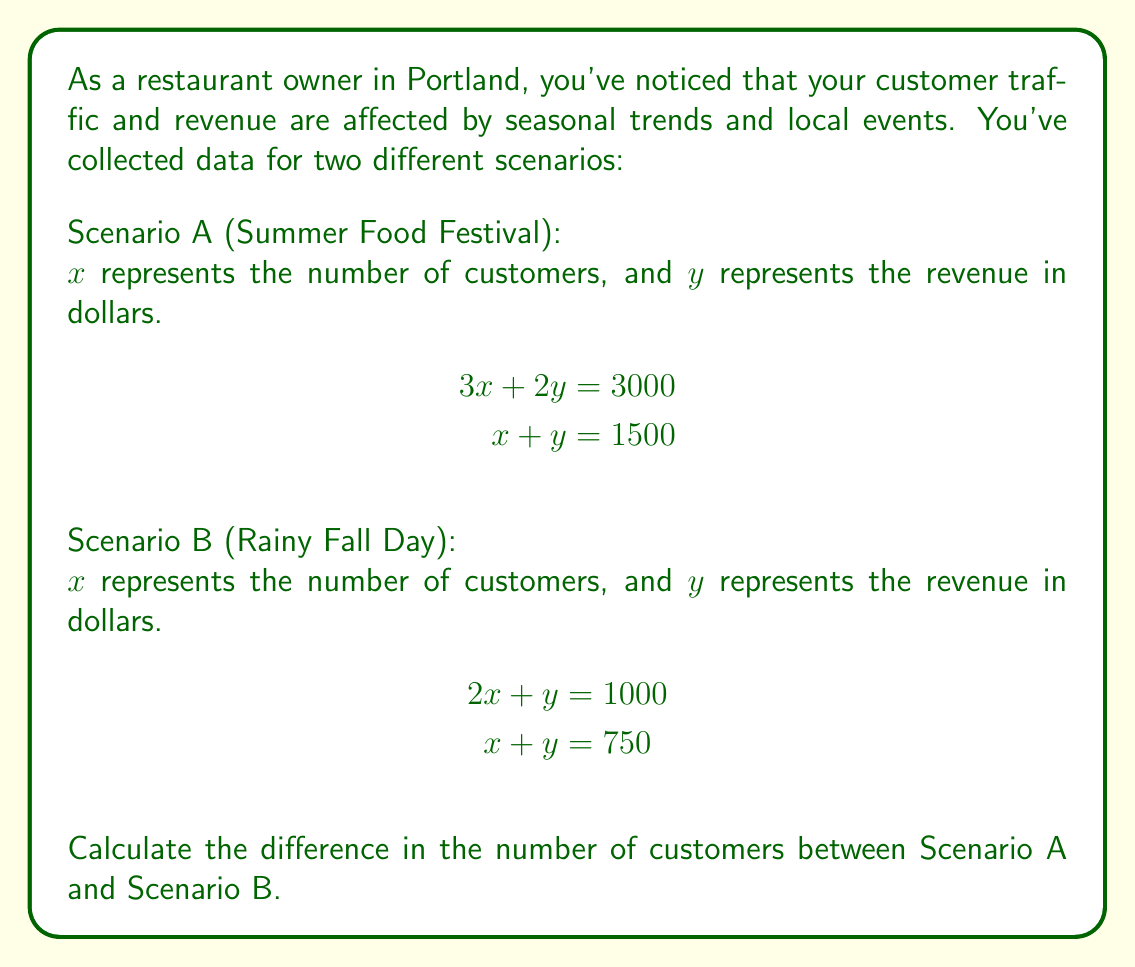Solve this math problem. Let's solve this problem step by step using systems of equations for each scenario:

Scenario A (Summer Food Festival):
$$3x + 2y = 3000 \quad (1)$$
$$x + y = 1500 \quad (2)$$

To solve this system, let's use substitution:
From equation (2): $y = 1500 - x$
Substitute this into equation (1):
$$3x + 2(1500 - x) = 3000$$
$$3x + 3000 - 2x = 3000$$
$$x = 1000$$

Now substitute $x = 1000$ back into equation (2):
$$1000 + y = 1500$$
$$y = 500$$

So, for Scenario A: $x_A = 1000$ customers, $y_A = 500$ dollars per customer

Scenario B (Rainy Fall Day):
$$2x + y = 1000 \quad (3)$$
$$x + y = 750 \quad (4)$$

Using substitution again:
From equation (4): $y = 750 - x$
Substitute this into equation (3):
$$2x + (750 - x) = 1000$$
$$2x + 750 - x = 1000$$
$$x = 250$$

Now substitute $x = 250$ back into equation (4):
$$250 + y = 750$$
$$y = 500$$

So, for Scenario B: $x_B = 250$ customers, $y_B = 500$ dollars per customer

To find the difference in the number of customers:
$$\text{Difference} = x_A - x_B = 1000 - 250 = 750$$
Answer: The difference in the number of customers between Scenario A (Summer Food Festival) and Scenario B (Rainy Fall Day) is 750 customers. 